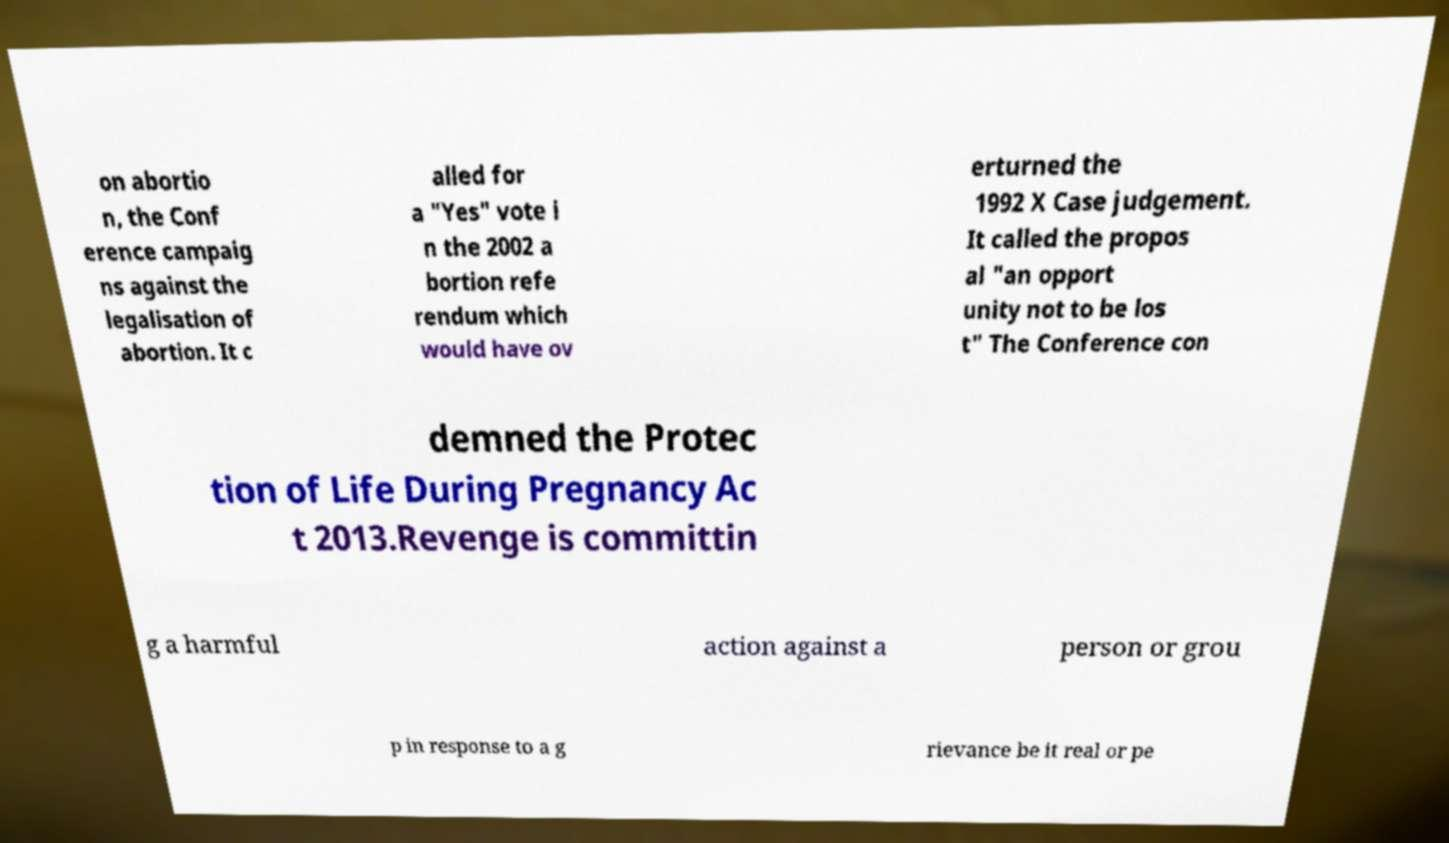I need the written content from this picture converted into text. Can you do that? on abortio n, the Conf erence campaig ns against the legalisation of abortion. It c alled for a "Yes" vote i n the 2002 a bortion refe rendum which would have ov erturned the 1992 X Case judgement. It called the propos al "an opport unity not to be los t" The Conference con demned the Protec tion of Life During Pregnancy Ac t 2013.Revenge is committin g a harmful action against a person or grou p in response to a g rievance be it real or pe 